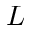Convert formula to latex. <formula><loc_0><loc_0><loc_500><loc_500>L</formula> 